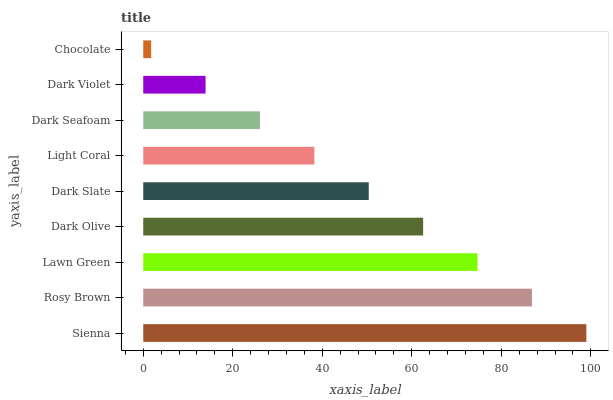Is Chocolate the minimum?
Answer yes or no. Yes. Is Sienna the maximum?
Answer yes or no. Yes. Is Rosy Brown the minimum?
Answer yes or no. No. Is Rosy Brown the maximum?
Answer yes or no. No. Is Sienna greater than Rosy Brown?
Answer yes or no. Yes. Is Rosy Brown less than Sienna?
Answer yes or no. Yes. Is Rosy Brown greater than Sienna?
Answer yes or no. No. Is Sienna less than Rosy Brown?
Answer yes or no. No. Is Dark Slate the high median?
Answer yes or no. Yes. Is Dark Slate the low median?
Answer yes or no. Yes. Is Rosy Brown the high median?
Answer yes or no. No. Is Dark Olive the low median?
Answer yes or no. No. 